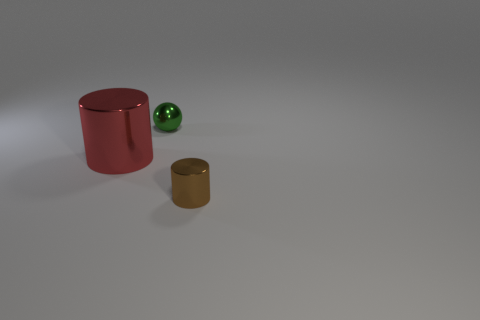Add 3 small green spheres. How many objects exist? 6 Subtract all cylinders. How many objects are left? 1 Add 3 green metal objects. How many green metal objects exist? 4 Subtract 0 yellow balls. How many objects are left? 3 Subtract all big yellow spheres. Subtract all shiny objects. How many objects are left? 0 Add 1 brown things. How many brown things are left? 2 